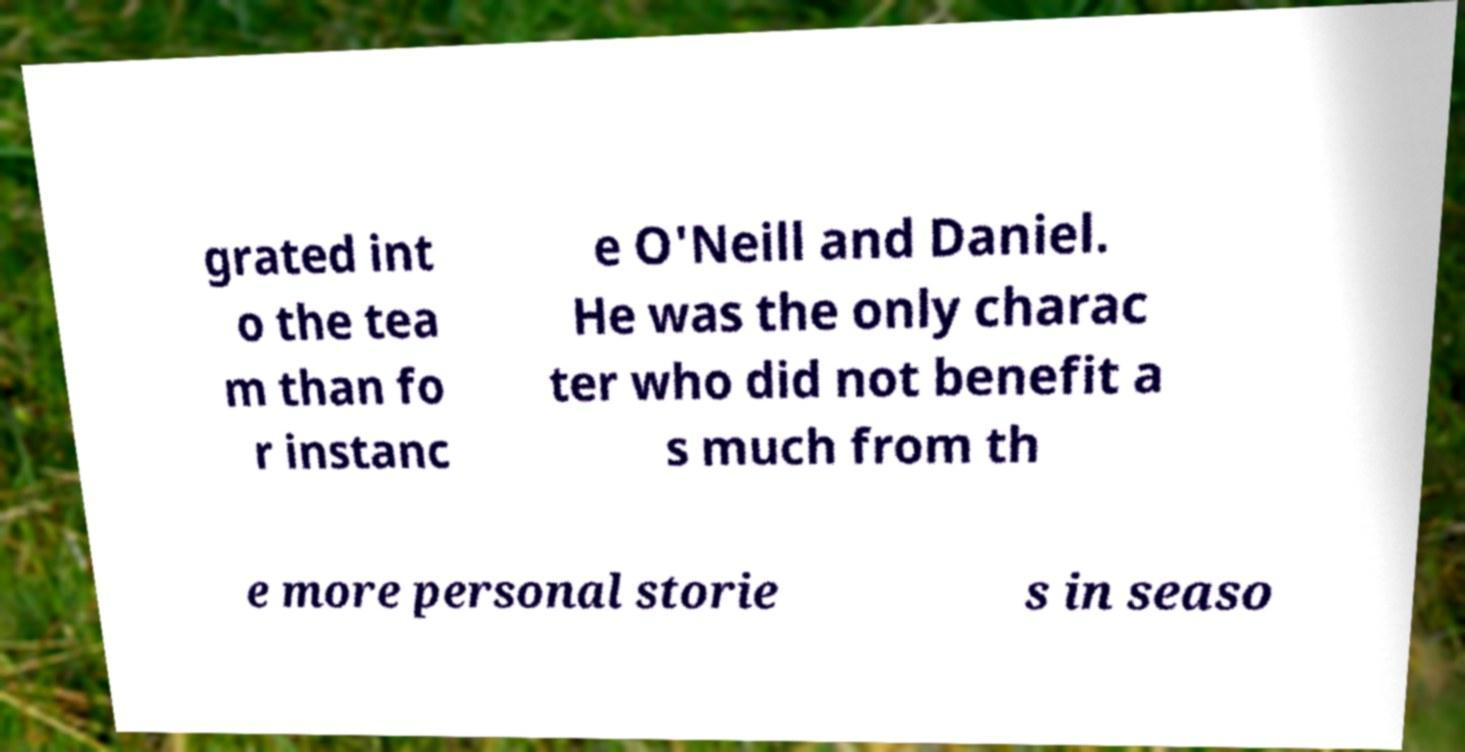Please read and relay the text visible in this image. What does it say? grated int o the tea m than fo r instanc e O'Neill and Daniel. He was the only charac ter who did not benefit a s much from th e more personal storie s in seaso 